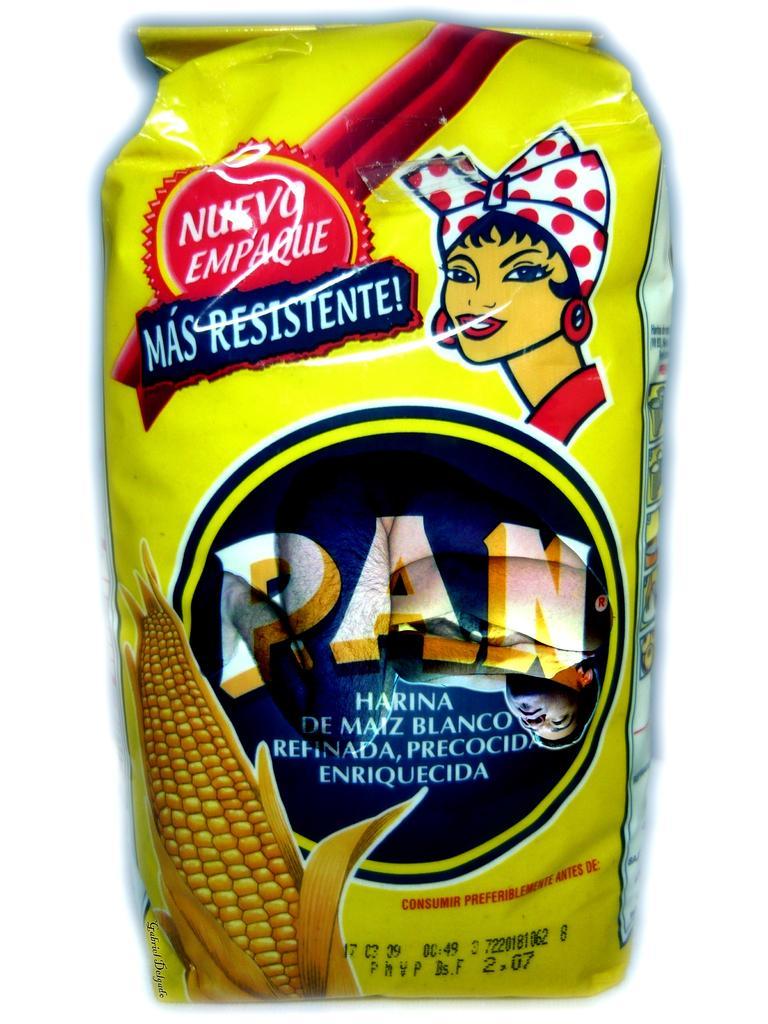In one or two sentences, can you explain what this image depicts? In this image we can see a packet. On the packet we can see picture of corn, people, and text written on it. 